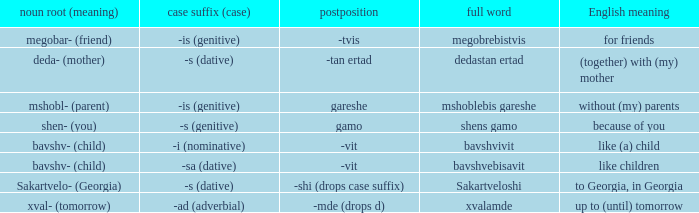What does it mean in english when the case suffix (case) is "-sa (dative)"? Like children. 